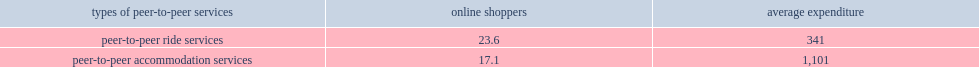What percent of online shoppers did they use peer-to-peer ride services? 23.6. What percent of online shoppers did they use peer-to-peer accommodation services? 17.1. What average expenditure did online shoppers who purchased peer-to-peer services spend on ride services? 341. What average expenditure did online shoppers spend on peer-to-peer accommodation services? 1101. 